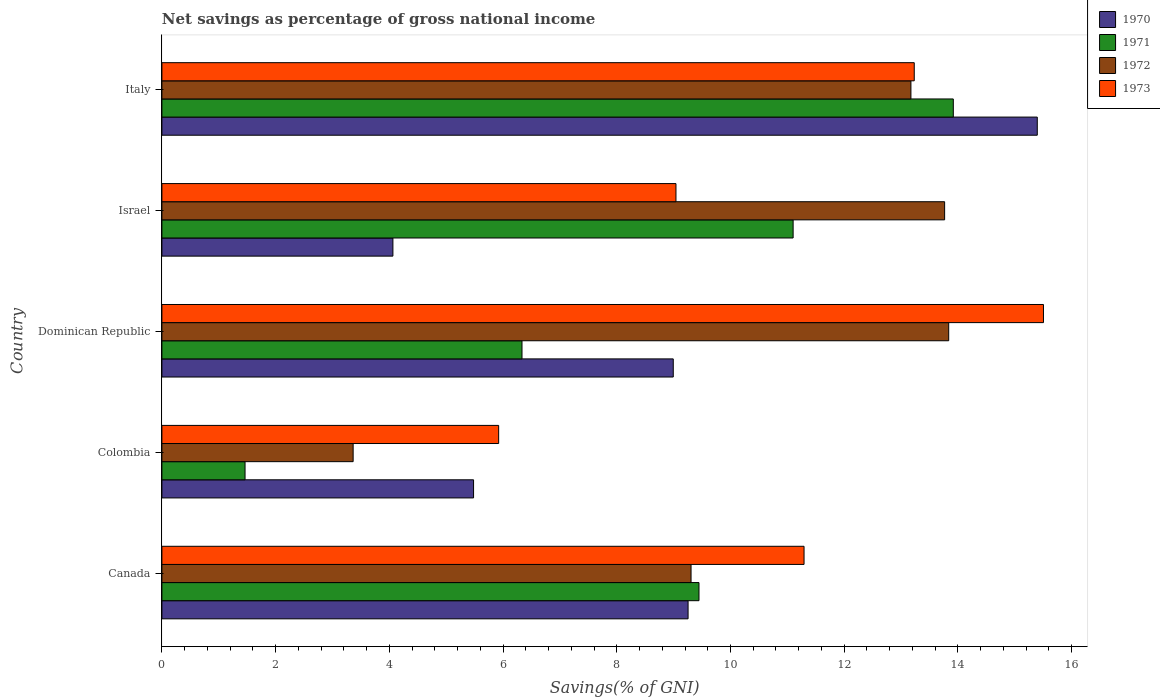How many different coloured bars are there?
Keep it short and to the point. 4. How many groups of bars are there?
Offer a very short reply. 5. How many bars are there on the 3rd tick from the top?
Offer a terse response. 4. What is the total savings in 1970 in Dominican Republic?
Give a very brief answer. 8.99. Across all countries, what is the maximum total savings in 1970?
Make the answer very short. 15.4. Across all countries, what is the minimum total savings in 1972?
Your answer should be compact. 3.36. In which country was the total savings in 1973 maximum?
Make the answer very short. Dominican Republic. In which country was the total savings in 1972 minimum?
Make the answer very short. Colombia. What is the total total savings in 1973 in the graph?
Provide a succinct answer. 54.99. What is the difference between the total savings in 1972 in Canada and that in Dominican Republic?
Keep it short and to the point. -4.53. What is the difference between the total savings in 1970 in Italy and the total savings in 1971 in Israel?
Your answer should be very brief. 4.29. What is the average total savings in 1971 per country?
Your answer should be compact. 8.45. What is the difference between the total savings in 1973 and total savings in 1971 in Canada?
Your answer should be very brief. 1.85. What is the ratio of the total savings in 1973 in Canada to that in Colombia?
Make the answer very short. 1.91. Is the total savings in 1972 in Colombia less than that in Italy?
Keep it short and to the point. Yes. Is the difference between the total savings in 1973 in Colombia and Israel greater than the difference between the total savings in 1971 in Colombia and Israel?
Provide a short and direct response. Yes. What is the difference between the highest and the second highest total savings in 1970?
Your answer should be compact. 6.14. What is the difference between the highest and the lowest total savings in 1972?
Your response must be concise. 10.47. In how many countries, is the total savings in 1972 greater than the average total savings in 1972 taken over all countries?
Provide a short and direct response. 3. Is the sum of the total savings in 1970 in Canada and Dominican Republic greater than the maximum total savings in 1973 across all countries?
Make the answer very short. Yes. Is it the case that in every country, the sum of the total savings in 1971 and total savings in 1972 is greater than the sum of total savings in 1973 and total savings in 1970?
Provide a short and direct response. No. What does the 2nd bar from the top in Canada represents?
Provide a short and direct response. 1972. How many bars are there?
Make the answer very short. 20. How many countries are there in the graph?
Your answer should be very brief. 5. What is the difference between two consecutive major ticks on the X-axis?
Your answer should be compact. 2. How are the legend labels stacked?
Make the answer very short. Vertical. What is the title of the graph?
Your answer should be compact. Net savings as percentage of gross national income. Does "1970" appear as one of the legend labels in the graph?
Make the answer very short. Yes. What is the label or title of the X-axis?
Offer a terse response. Savings(% of GNI). What is the Savings(% of GNI) in 1970 in Canada?
Your response must be concise. 9.25. What is the Savings(% of GNI) of 1971 in Canada?
Your response must be concise. 9.45. What is the Savings(% of GNI) of 1972 in Canada?
Give a very brief answer. 9.31. What is the Savings(% of GNI) of 1973 in Canada?
Offer a very short reply. 11.29. What is the Savings(% of GNI) in 1970 in Colombia?
Provide a short and direct response. 5.48. What is the Savings(% of GNI) of 1971 in Colombia?
Ensure brevity in your answer.  1.46. What is the Savings(% of GNI) in 1972 in Colombia?
Your response must be concise. 3.36. What is the Savings(% of GNI) of 1973 in Colombia?
Offer a very short reply. 5.92. What is the Savings(% of GNI) in 1970 in Dominican Republic?
Offer a very short reply. 8.99. What is the Savings(% of GNI) of 1971 in Dominican Republic?
Your answer should be compact. 6.33. What is the Savings(% of GNI) in 1972 in Dominican Republic?
Your response must be concise. 13.84. What is the Savings(% of GNI) in 1973 in Dominican Republic?
Offer a terse response. 15.5. What is the Savings(% of GNI) in 1970 in Israel?
Offer a very short reply. 4.06. What is the Savings(% of GNI) in 1971 in Israel?
Provide a short and direct response. 11.1. What is the Savings(% of GNI) of 1972 in Israel?
Give a very brief answer. 13.77. What is the Savings(% of GNI) of 1973 in Israel?
Your response must be concise. 9.04. What is the Savings(% of GNI) of 1970 in Italy?
Provide a succinct answer. 15.4. What is the Savings(% of GNI) of 1971 in Italy?
Offer a terse response. 13.92. What is the Savings(% of GNI) in 1972 in Italy?
Your response must be concise. 13.17. What is the Savings(% of GNI) in 1973 in Italy?
Offer a terse response. 13.23. Across all countries, what is the maximum Savings(% of GNI) of 1970?
Ensure brevity in your answer.  15.4. Across all countries, what is the maximum Savings(% of GNI) in 1971?
Provide a succinct answer. 13.92. Across all countries, what is the maximum Savings(% of GNI) of 1972?
Provide a short and direct response. 13.84. Across all countries, what is the maximum Savings(% of GNI) in 1973?
Offer a very short reply. 15.5. Across all countries, what is the minimum Savings(% of GNI) of 1970?
Provide a succinct answer. 4.06. Across all countries, what is the minimum Savings(% of GNI) in 1971?
Ensure brevity in your answer.  1.46. Across all countries, what is the minimum Savings(% of GNI) of 1972?
Offer a very short reply. 3.36. Across all countries, what is the minimum Savings(% of GNI) of 1973?
Keep it short and to the point. 5.92. What is the total Savings(% of GNI) in 1970 in the graph?
Offer a very short reply. 43.19. What is the total Savings(% of GNI) in 1971 in the graph?
Provide a succinct answer. 42.26. What is the total Savings(% of GNI) in 1972 in the graph?
Offer a very short reply. 53.45. What is the total Savings(% of GNI) in 1973 in the graph?
Your answer should be very brief. 54.99. What is the difference between the Savings(% of GNI) of 1970 in Canada and that in Colombia?
Offer a terse response. 3.77. What is the difference between the Savings(% of GNI) in 1971 in Canada and that in Colombia?
Provide a succinct answer. 7.98. What is the difference between the Savings(% of GNI) in 1972 in Canada and that in Colombia?
Your response must be concise. 5.94. What is the difference between the Savings(% of GNI) in 1973 in Canada and that in Colombia?
Make the answer very short. 5.37. What is the difference between the Savings(% of GNI) in 1970 in Canada and that in Dominican Republic?
Offer a very short reply. 0.26. What is the difference between the Savings(% of GNI) of 1971 in Canada and that in Dominican Republic?
Offer a very short reply. 3.11. What is the difference between the Savings(% of GNI) of 1972 in Canada and that in Dominican Republic?
Offer a very short reply. -4.53. What is the difference between the Savings(% of GNI) in 1973 in Canada and that in Dominican Republic?
Provide a succinct answer. -4.21. What is the difference between the Savings(% of GNI) of 1970 in Canada and that in Israel?
Give a very brief answer. 5.19. What is the difference between the Savings(% of GNI) of 1971 in Canada and that in Israel?
Make the answer very short. -1.66. What is the difference between the Savings(% of GNI) in 1972 in Canada and that in Israel?
Your response must be concise. -4.46. What is the difference between the Savings(% of GNI) of 1973 in Canada and that in Israel?
Offer a terse response. 2.25. What is the difference between the Savings(% of GNI) of 1970 in Canada and that in Italy?
Give a very brief answer. -6.14. What is the difference between the Savings(% of GNI) of 1971 in Canada and that in Italy?
Keep it short and to the point. -4.47. What is the difference between the Savings(% of GNI) of 1972 in Canada and that in Italy?
Make the answer very short. -3.87. What is the difference between the Savings(% of GNI) of 1973 in Canada and that in Italy?
Your response must be concise. -1.94. What is the difference between the Savings(% of GNI) in 1970 in Colombia and that in Dominican Republic?
Make the answer very short. -3.51. What is the difference between the Savings(% of GNI) in 1971 in Colombia and that in Dominican Republic?
Offer a terse response. -4.87. What is the difference between the Savings(% of GNI) in 1972 in Colombia and that in Dominican Republic?
Your answer should be compact. -10.47. What is the difference between the Savings(% of GNI) in 1973 in Colombia and that in Dominican Republic?
Offer a terse response. -9.58. What is the difference between the Savings(% of GNI) of 1970 in Colombia and that in Israel?
Your answer should be very brief. 1.42. What is the difference between the Savings(% of GNI) of 1971 in Colombia and that in Israel?
Offer a terse response. -9.64. What is the difference between the Savings(% of GNI) of 1972 in Colombia and that in Israel?
Ensure brevity in your answer.  -10.4. What is the difference between the Savings(% of GNI) in 1973 in Colombia and that in Israel?
Your answer should be very brief. -3.12. What is the difference between the Savings(% of GNI) in 1970 in Colombia and that in Italy?
Give a very brief answer. -9.91. What is the difference between the Savings(% of GNI) in 1971 in Colombia and that in Italy?
Provide a succinct answer. -12.46. What is the difference between the Savings(% of GNI) of 1972 in Colombia and that in Italy?
Your answer should be compact. -9.81. What is the difference between the Savings(% of GNI) in 1973 in Colombia and that in Italy?
Offer a very short reply. -7.31. What is the difference between the Savings(% of GNI) of 1970 in Dominican Republic and that in Israel?
Your response must be concise. 4.93. What is the difference between the Savings(% of GNI) in 1971 in Dominican Republic and that in Israel?
Provide a succinct answer. -4.77. What is the difference between the Savings(% of GNI) in 1972 in Dominican Republic and that in Israel?
Keep it short and to the point. 0.07. What is the difference between the Savings(% of GNI) of 1973 in Dominican Republic and that in Israel?
Ensure brevity in your answer.  6.46. What is the difference between the Savings(% of GNI) of 1970 in Dominican Republic and that in Italy?
Offer a terse response. -6.4. What is the difference between the Savings(% of GNI) in 1971 in Dominican Republic and that in Italy?
Offer a very short reply. -7.59. What is the difference between the Savings(% of GNI) in 1972 in Dominican Republic and that in Italy?
Your response must be concise. 0.66. What is the difference between the Savings(% of GNI) of 1973 in Dominican Republic and that in Italy?
Your answer should be very brief. 2.27. What is the difference between the Savings(% of GNI) in 1970 in Israel and that in Italy?
Offer a terse response. -11.33. What is the difference between the Savings(% of GNI) of 1971 in Israel and that in Italy?
Ensure brevity in your answer.  -2.82. What is the difference between the Savings(% of GNI) in 1972 in Israel and that in Italy?
Give a very brief answer. 0.59. What is the difference between the Savings(% of GNI) of 1973 in Israel and that in Italy?
Offer a terse response. -4.19. What is the difference between the Savings(% of GNI) in 1970 in Canada and the Savings(% of GNI) in 1971 in Colombia?
Give a very brief answer. 7.79. What is the difference between the Savings(% of GNI) of 1970 in Canada and the Savings(% of GNI) of 1972 in Colombia?
Your response must be concise. 5.89. What is the difference between the Savings(% of GNI) of 1970 in Canada and the Savings(% of GNI) of 1973 in Colombia?
Give a very brief answer. 3.33. What is the difference between the Savings(% of GNI) in 1971 in Canada and the Savings(% of GNI) in 1972 in Colombia?
Your answer should be compact. 6.08. What is the difference between the Savings(% of GNI) of 1971 in Canada and the Savings(% of GNI) of 1973 in Colombia?
Ensure brevity in your answer.  3.52. What is the difference between the Savings(% of GNI) of 1972 in Canada and the Savings(% of GNI) of 1973 in Colombia?
Ensure brevity in your answer.  3.38. What is the difference between the Savings(% of GNI) of 1970 in Canada and the Savings(% of GNI) of 1971 in Dominican Republic?
Keep it short and to the point. 2.92. What is the difference between the Savings(% of GNI) of 1970 in Canada and the Savings(% of GNI) of 1972 in Dominican Republic?
Your response must be concise. -4.58. What is the difference between the Savings(% of GNI) in 1970 in Canada and the Savings(% of GNI) in 1973 in Dominican Republic?
Your answer should be very brief. -6.25. What is the difference between the Savings(% of GNI) in 1971 in Canada and the Savings(% of GNI) in 1972 in Dominican Republic?
Your answer should be compact. -4.39. What is the difference between the Savings(% of GNI) of 1971 in Canada and the Savings(% of GNI) of 1973 in Dominican Republic?
Your answer should be very brief. -6.06. What is the difference between the Savings(% of GNI) in 1972 in Canada and the Savings(% of GNI) in 1973 in Dominican Republic?
Provide a short and direct response. -6.2. What is the difference between the Savings(% of GNI) in 1970 in Canada and the Savings(% of GNI) in 1971 in Israel?
Your response must be concise. -1.85. What is the difference between the Savings(% of GNI) in 1970 in Canada and the Savings(% of GNI) in 1972 in Israel?
Your answer should be compact. -4.51. What is the difference between the Savings(% of GNI) in 1970 in Canada and the Savings(% of GNI) in 1973 in Israel?
Provide a short and direct response. 0.21. What is the difference between the Savings(% of GNI) of 1971 in Canada and the Savings(% of GNI) of 1972 in Israel?
Ensure brevity in your answer.  -4.32. What is the difference between the Savings(% of GNI) in 1971 in Canada and the Savings(% of GNI) in 1973 in Israel?
Give a very brief answer. 0.4. What is the difference between the Savings(% of GNI) of 1972 in Canada and the Savings(% of GNI) of 1973 in Israel?
Provide a short and direct response. 0.27. What is the difference between the Savings(% of GNI) of 1970 in Canada and the Savings(% of GNI) of 1971 in Italy?
Your answer should be very brief. -4.66. What is the difference between the Savings(% of GNI) in 1970 in Canada and the Savings(% of GNI) in 1972 in Italy?
Provide a short and direct response. -3.92. What is the difference between the Savings(% of GNI) in 1970 in Canada and the Savings(% of GNI) in 1973 in Italy?
Give a very brief answer. -3.98. What is the difference between the Savings(% of GNI) in 1971 in Canada and the Savings(% of GNI) in 1972 in Italy?
Ensure brevity in your answer.  -3.73. What is the difference between the Savings(% of GNI) in 1971 in Canada and the Savings(% of GNI) in 1973 in Italy?
Offer a very short reply. -3.79. What is the difference between the Savings(% of GNI) of 1972 in Canada and the Savings(% of GNI) of 1973 in Italy?
Your response must be concise. -3.93. What is the difference between the Savings(% of GNI) of 1970 in Colombia and the Savings(% of GNI) of 1971 in Dominican Republic?
Offer a terse response. -0.85. What is the difference between the Savings(% of GNI) of 1970 in Colombia and the Savings(% of GNI) of 1972 in Dominican Republic?
Your answer should be very brief. -8.36. What is the difference between the Savings(% of GNI) in 1970 in Colombia and the Savings(% of GNI) in 1973 in Dominican Republic?
Your response must be concise. -10.02. What is the difference between the Savings(% of GNI) in 1971 in Colombia and the Savings(% of GNI) in 1972 in Dominican Republic?
Your response must be concise. -12.38. What is the difference between the Savings(% of GNI) of 1971 in Colombia and the Savings(% of GNI) of 1973 in Dominican Republic?
Your answer should be very brief. -14.04. What is the difference between the Savings(% of GNI) in 1972 in Colombia and the Savings(% of GNI) in 1973 in Dominican Republic?
Your answer should be compact. -12.14. What is the difference between the Savings(% of GNI) in 1970 in Colombia and the Savings(% of GNI) in 1971 in Israel?
Provide a succinct answer. -5.62. What is the difference between the Savings(% of GNI) of 1970 in Colombia and the Savings(% of GNI) of 1972 in Israel?
Your answer should be very brief. -8.28. What is the difference between the Savings(% of GNI) of 1970 in Colombia and the Savings(% of GNI) of 1973 in Israel?
Keep it short and to the point. -3.56. What is the difference between the Savings(% of GNI) of 1971 in Colombia and the Savings(% of GNI) of 1972 in Israel?
Give a very brief answer. -12.3. What is the difference between the Savings(% of GNI) of 1971 in Colombia and the Savings(% of GNI) of 1973 in Israel?
Your answer should be compact. -7.58. What is the difference between the Savings(% of GNI) of 1972 in Colombia and the Savings(% of GNI) of 1973 in Israel?
Provide a succinct answer. -5.68. What is the difference between the Savings(% of GNI) of 1970 in Colombia and the Savings(% of GNI) of 1971 in Italy?
Your answer should be very brief. -8.44. What is the difference between the Savings(% of GNI) in 1970 in Colombia and the Savings(% of GNI) in 1972 in Italy?
Provide a succinct answer. -7.69. What is the difference between the Savings(% of GNI) in 1970 in Colombia and the Savings(% of GNI) in 1973 in Italy?
Keep it short and to the point. -7.75. What is the difference between the Savings(% of GNI) of 1971 in Colombia and the Savings(% of GNI) of 1972 in Italy?
Give a very brief answer. -11.71. What is the difference between the Savings(% of GNI) of 1971 in Colombia and the Savings(% of GNI) of 1973 in Italy?
Give a very brief answer. -11.77. What is the difference between the Savings(% of GNI) in 1972 in Colombia and the Savings(% of GNI) in 1973 in Italy?
Your response must be concise. -9.87. What is the difference between the Savings(% of GNI) of 1970 in Dominican Republic and the Savings(% of GNI) of 1971 in Israel?
Your answer should be very brief. -2.11. What is the difference between the Savings(% of GNI) in 1970 in Dominican Republic and the Savings(% of GNI) in 1972 in Israel?
Make the answer very short. -4.77. What is the difference between the Savings(% of GNI) of 1970 in Dominican Republic and the Savings(% of GNI) of 1973 in Israel?
Your answer should be very brief. -0.05. What is the difference between the Savings(% of GNI) of 1971 in Dominican Republic and the Savings(% of GNI) of 1972 in Israel?
Give a very brief answer. -7.43. What is the difference between the Savings(% of GNI) of 1971 in Dominican Republic and the Savings(% of GNI) of 1973 in Israel?
Make the answer very short. -2.71. What is the difference between the Savings(% of GNI) of 1972 in Dominican Republic and the Savings(% of GNI) of 1973 in Israel?
Offer a terse response. 4.8. What is the difference between the Savings(% of GNI) of 1970 in Dominican Republic and the Savings(% of GNI) of 1971 in Italy?
Offer a terse response. -4.93. What is the difference between the Savings(% of GNI) in 1970 in Dominican Republic and the Savings(% of GNI) in 1972 in Italy?
Your answer should be very brief. -4.18. What is the difference between the Savings(% of GNI) in 1970 in Dominican Republic and the Savings(% of GNI) in 1973 in Italy?
Ensure brevity in your answer.  -4.24. What is the difference between the Savings(% of GNI) of 1971 in Dominican Republic and the Savings(% of GNI) of 1972 in Italy?
Your response must be concise. -6.84. What is the difference between the Savings(% of GNI) in 1971 in Dominican Republic and the Savings(% of GNI) in 1973 in Italy?
Give a very brief answer. -6.9. What is the difference between the Savings(% of GNI) of 1972 in Dominican Republic and the Savings(% of GNI) of 1973 in Italy?
Your answer should be very brief. 0.61. What is the difference between the Savings(% of GNI) in 1970 in Israel and the Savings(% of GNI) in 1971 in Italy?
Offer a terse response. -9.86. What is the difference between the Savings(% of GNI) in 1970 in Israel and the Savings(% of GNI) in 1972 in Italy?
Provide a succinct answer. -9.11. What is the difference between the Savings(% of GNI) in 1970 in Israel and the Savings(% of GNI) in 1973 in Italy?
Give a very brief answer. -9.17. What is the difference between the Savings(% of GNI) in 1971 in Israel and the Savings(% of GNI) in 1972 in Italy?
Your response must be concise. -2.07. What is the difference between the Savings(% of GNI) in 1971 in Israel and the Savings(% of GNI) in 1973 in Italy?
Your answer should be very brief. -2.13. What is the difference between the Savings(% of GNI) of 1972 in Israel and the Savings(% of GNI) of 1973 in Italy?
Your response must be concise. 0.53. What is the average Savings(% of GNI) in 1970 per country?
Provide a succinct answer. 8.64. What is the average Savings(% of GNI) of 1971 per country?
Provide a succinct answer. 8.45. What is the average Savings(% of GNI) in 1972 per country?
Ensure brevity in your answer.  10.69. What is the average Savings(% of GNI) of 1973 per country?
Give a very brief answer. 11. What is the difference between the Savings(% of GNI) of 1970 and Savings(% of GNI) of 1971 in Canada?
Offer a terse response. -0.19. What is the difference between the Savings(% of GNI) in 1970 and Savings(% of GNI) in 1972 in Canada?
Provide a succinct answer. -0.05. What is the difference between the Savings(% of GNI) of 1970 and Savings(% of GNI) of 1973 in Canada?
Offer a very short reply. -2.04. What is the difference between the Savings(% of GNI) in 1971 and Savings(% of GNI) in 1972 in Canada?
Make the answer very short. 0.14. What is the difference between the Savings(% of GNI) of 1971 and Savings(% of GNI) of 1973 in Canada?
Offer a very short reply. -1.85. What is the difference between the Savings(% of GNI) of 1972 and Savings(% of GNI) of 1973 in Canada?
Give a very brief answer. -1.99. What is the difference between the Savings(% of GNI) of 1970 and Savings(% of GNI) of 1971 in Colombia?
Your response must be concise. 4.02. What is the difference between the Savings(% of GNI) of 1970 and Savings(% of GNI) of 1972 in Colombia?
Offer a terse response. 2.12. What is the difference between the Savings(% of GNI) of 1970 and Savings(% of GNI) of 1973 in Colombia?
Provide a short and direct response. -0.44. What is the difference between the Savings(% of GNI) of 1971 and Savings(% of GNI) of 1972 in Colombia?
Your answer should be compact. -1.9. What is the difference between the Savings(% of GNI) in 1971 and Savings(% of GNI) in 1973 in Colombia?
Make the answer very short. -4.46. What is the difference between the Savings(% of GNI) of 1972 and Savings(% of GNI) of 1973 in Colombia?
Your response must be concise. -2.56. What is the difference between the Savings(% of GNI) in 1970 and Savings(% of GNI) in 1971 in Dominican Republic?
Give a very brief answer. 2.66. What is the difference between the Savings(% of GNI) of 1970 and Savings(% of GNI) of 1972 in Dominican Republic?
Offer a very short reply. -4.84. What is the difference between the Savings(% of GNI) of 1970 and Savings(% of GNI) of 1973 in Dominican Republic?
Your answer should be compact. -6.51. What is the difference between the Savings(% of GNI) in 1971 and Savings(% of GNI) in 1972 in Dominican Republic?
Make the answer very short. -7.5. What is the difference between the Savings(% of GNI) of 1971 and Savings(% of GNI) of 1973 in Dominican Republic?
Provide a short and direct response. -9.17. What is the difference between the Savings(% of GNI) of 1972 and Savings(% of GNI) of 1973 in Dominican Republic?
Your answer should be compact. -1.67. What is the difference between the Savings(% of GNI) in 1970 and Savings(% of GNI) in 1971 in Israel?
Your answer should be very brief. -7.04. What is the difference between the Savings(% of GNI) of 1970 and Savings(% of GNI) of 1972 in Israel?
Your response must be concise. -9.7. What is the difference between the Savings(% of GNI) in 1970 and Savings(% of GNI) in 1973 in Israel?
Provide a succinct answer. -4.98. What is the difference between the Savings(% of GNI) of 1971 and Savings(% of GNI) of 1972 in Israel?
Provide a succinct answer. -2.66. What is the difference between the Savings(% of GNI) of 1971 and Savings(% of GNI) of 1973 in Israel?
Your answer should be very brief. 2.06. What is the difference between the Savings(% of GNI) in 1972 and Savings(% of GNI) in 1973 in Israel?
Give a very brief answer. 4.73. What is the difference between the Savings(% of GNI) in 1970 and Savings(% of GNI) in 1971 in Italy?
Provide a succinct answer. 1.48. What is the difference between the Savings(% of GNI) of 1970 and Savings(% of GNI) of 1972 in Italy?
Make the answer very short. 2.22. What is the difference between the Savings(% of GNI) in 1970 and Savings(% of GNI) in 1973 in Italy?
Your answer should be compact. 2.16. What is the difference between the Savings(% of GNI) of 1971 and Savings(% of GNI) of 1972 in Italy?
Make the answer very short. 0.75. What is the difference between the Savings(% of GNI) in 1971 and Savings(% of GNI) in 1973 in Italy?
Provide a succinct answer. 0.69. What is the difference between the Savings(% of GNI) of 1972 and Savings(% of GNI) of 1973 in Italy?
Your answer should be compact. -0.06. What is the ratio of the Savings(% of GNI) in 1970 in Canada to that in Colombia?
Offer a terse response. 1.69. What is the ratio of the Savings(% of GNI) in 1971 in Canada to that in Colombia?
Give a very brief answer. 6.46. What is the ratio of the Savings(% of GNI) in 1972 in Canada to that in Colombia?
Ensure brevity in your answer.  2.77. What is the ratio of the Savings(% of GNI) of 1973 in Canada to that in Colombia?
Offer a very short reply. 1.91. What is the ratio of the Savings(% of GNI) of 1971 in Canada to that in Dominican Republic?
Your answer should be very brief. 1.49. What is the ratio of the Savings(% of GNI) in 1972 in Canada to that in Dominican Republic?
Give a very brief answer. 0.67. What is the ratio of the Savings(% of GNI) in 1973 in Canada to that in Dominican Republic?
Keep it short and to the point. 0.73. What is the ratio of the Savings(% of GNI) in 1970 in Canada to that in Israel?
Your answer should be compact. 2.28. What is the ratio of the Savings(% of GNI) of 1971 in Canada to that in Israel?
Give a very brief answer. 0.85. What is the ratio of the Savings(% of GNI) in 1972 in Canada to that in Israel?
Provide a succinct answer. 0.68. What is the ratio of the Savings(% of GNI) of 1973 in Canada to that in Israel?
Ensure brevity in your answer.  1.25. What is the ratio of the Savings(% of GNI) of 1970 in Canada to that in Italy?
Offer a terse response. 0.6. What is the ratio of the Savings(% of GNI) in 1971 in Canada to that in Italy?
Offer a terse response. 0.68. What is the ratio of the Savings(% of GNI) in 1972 in Canada to that in Italy?
Keep it short and to the point. 0.71. What is the ratio of the Savings(% of GNI) in 1973 in Canada to that in Italy?
Your answer should be very brief. 0.85. What is the ratio of the Savings(% of GNI) in 1970 in Colombia to that in Dominican Republic?
Make the answer very short. 0.61. What is the ratio of the Savings(% of GNI) of 1971 in Colombia to that in Dominican Republic?
Your response must be concise. 0.23. What is the ratio of the Savings(% of GNI) of 1972 in Colombia to that in Dominican Republic?
Make the answer very short. 0.24. What is the ratio of the Savings(% of GNI) in 1973 in Colombia to that in Dominican Republic?
Offer a terse response. 0.38. What is the ratio of the Savings(% of GNI) of 1970 in Colombia to that in Israel?
Your answer should be compact. 1.35. What is the ratio of the Savings(% of GNI) in 1971 in Colombia to that in Israel?
Make the answer very short. 0.13. What is the ratio of the Savings(% of GNI) of 1972 in Colombia to that in Israel?
Offer a terse response. 0.24. What is the ratio of the Savings(% of GNI) in 1973 in Colombia to that in Israel?
Your answer should be very brief. 0.66. What is the ratio of the Savings(% of GNI) of 1970 in Colombia to that in Italy?
Make the answer very short. 0.36. What is the ratio of the Savings(% of GNI) of 1971 in Colombia to that in Italy?
Offer a terse response. 0.11. What is the ratio of the Savings(% of GNI) of 1972 in Colombia to that in Italy?
Ensure brevity in your answer.  0.26. What is the ratio of the Savings(% of GNI) of 1973 in Colombia to that in Italy?
Keep it short and to the point. 0.45. What is the ratio of the Savings(% of GNI) in 1970 in Dominican Republic to that in Israel?
Keep it short and to the point. 2.21. What is the ratio of the Savings(% of GNI) of 1971 in Dominican Republic to that in Israel?
Your response must be concise. 0.57. What is the ratio of the Savings(% of GNI) of 1973 in Dominican Republic to that in Israel?
Provide a succinct answer. 1.71. What is the ratio of the Savings(% of GNI) in 1970 in Dominican Republic to that in Italy?
Offer a terse response. 0.58. What is the ratio of the Savings(% of GNI) of 1971 in Dominican Republic to that in Italy?
Your answer should be compact. 0.46. What is the ratio of the Savings(% of GNI) of 1972 in Dominican Republic to that in Italy?
Your answer should be compact. 1.05. What is the ratio of the Savings(% of GNI) in 1973 in Dominican Republic to that in Italy?
Your answer should be very brief. 1.17. What is the ratio of the Savings(% of GNI) in 1970 in Israel to that in Italy?
Keep it short and to the point. 0.26. What is the ratio of the Savings(% of GNI) of 1971 in Israel to that in Italy?
Offer a very short reply. 0.8. What is the ratio of the Savings(% of GNI) in 1972 in Israel to that in Italy?
Your answer should be compact. 1.04. What is the ratio of the Savings(% of GNI) of 1973 in Israel to that in Italy?
Your answer should be very brief. 0.68. What is the difference between the highest and the second highest Savings(% of GNI) of 1970?
Make the answer very short. 6.14. What is the difference between the highest and the second highest Savings(% of GNI) of 1971?
Ensure brevity in your answer.  2.82. What is the difference between the highest and the second highest Savings(% of GNI) of 1972?
Provide a short and direct response. 0.07. What is the difference between the highest and the second highest Savings(% of GNI) of 1973?
Provide a short and direct response. 2.27. What is the difference between the highest and the lowest Savings(% of GNI) in 1970?
Your answer should be very brief. 11.33. What is the difference between the highest and the lowest Savings(% of GNI) in 1971?
Ensure brevity in your answer.  12.46. What is the difference between the highest and the lowest Savings(% of GNI) of 1972?
Offer a terse response. 10.47. What is the difference between the highest and the lowest Savings(% of GNI) in 1973?
Provide a short and direct response. 9.58. 